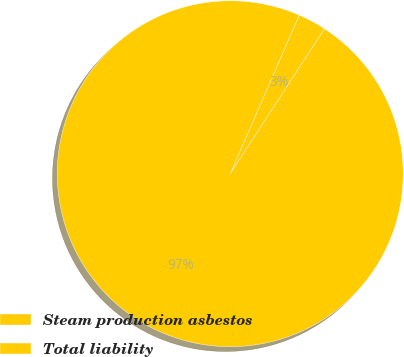Convert chart to OTSL. <chart><loc_0><loc_0><loc_500><loc_500><pie_chart><fcel>Steam production asbestos<fcel>Total liability<nl><fcel>2.65%<fcel>97.35%<nl></chart> 